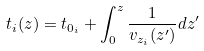<formula> <loc_0><loc_0><loc_500><loc_500>t _ { i } ( z ) = t _ { 0 _ { i } } + \int _ { 0 } ^ { z } \frac { 1 } { v _ { z _ { i } } ( z ^ { \prime } ) } d z ^ { \prime }</formula> 